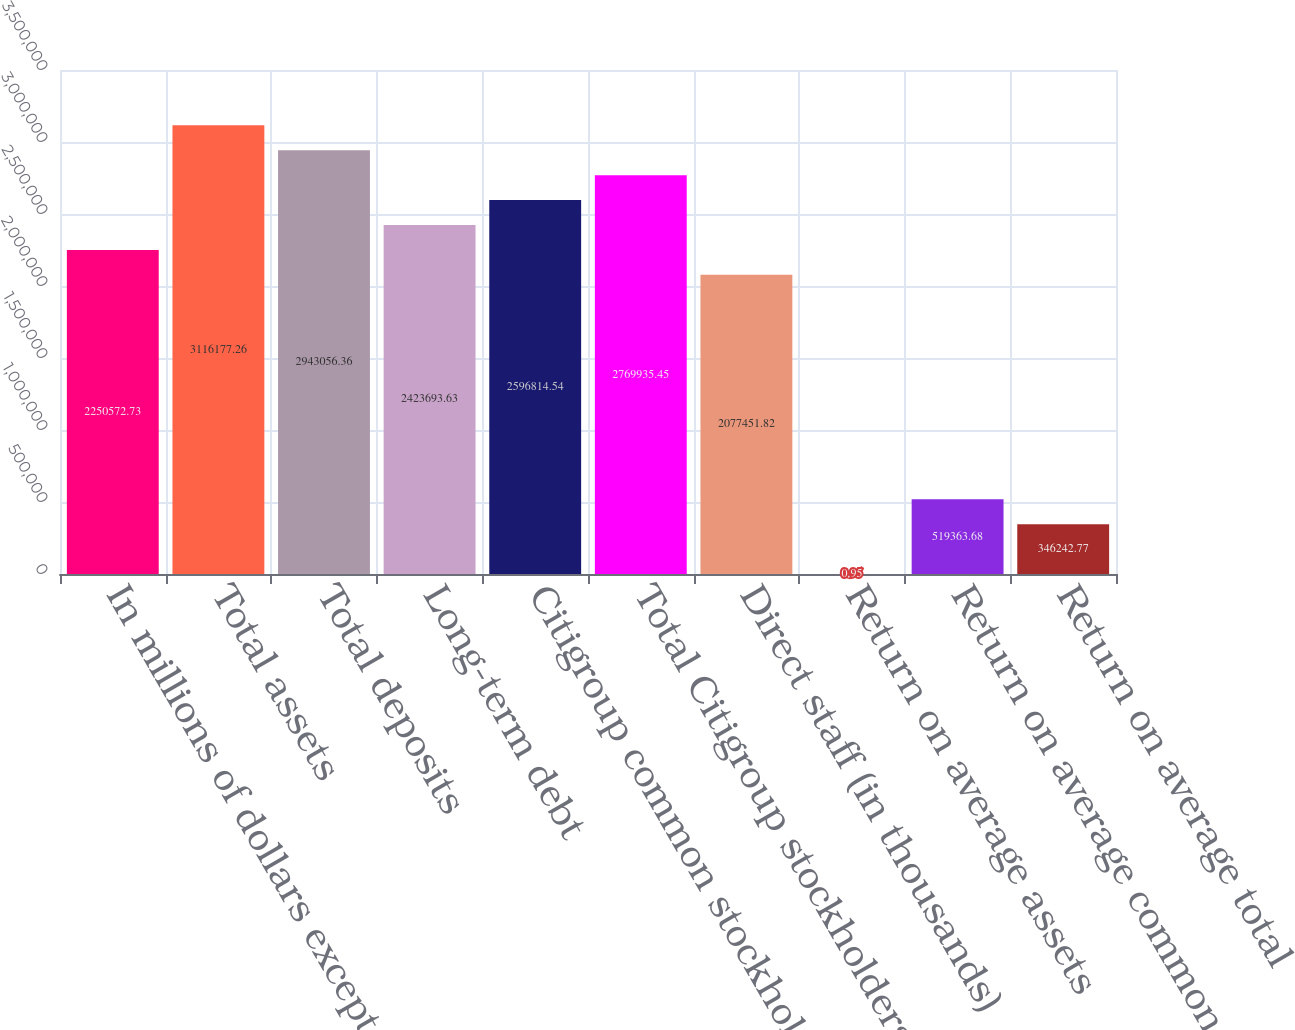Convert chart. <chart><loc_0><loc_0><loc_500><loc_500><bar_chart><fcel>In millions of dollars except<fcel>Total assets<fcel>Total deposits<fcel>Long-term debt<fcel>Citigroup common stockholders'<fcel>Total Citigroup stockholders'<fcel>Direct staff (in thousands)<fcel>Return on average assets<fcel>Return on average common<fcel>Return on average total<nl><fcel>2.25057e+06<fcel>3.11618e+06<fcel>2.94306e+06<fcel>2.42369e+06<fcel>2.59681e+06<fcel>2.76994e+06<fcel>2.07745e+06<fcel>0.95<fcel>519364<fcel>346243<nl></chart> 